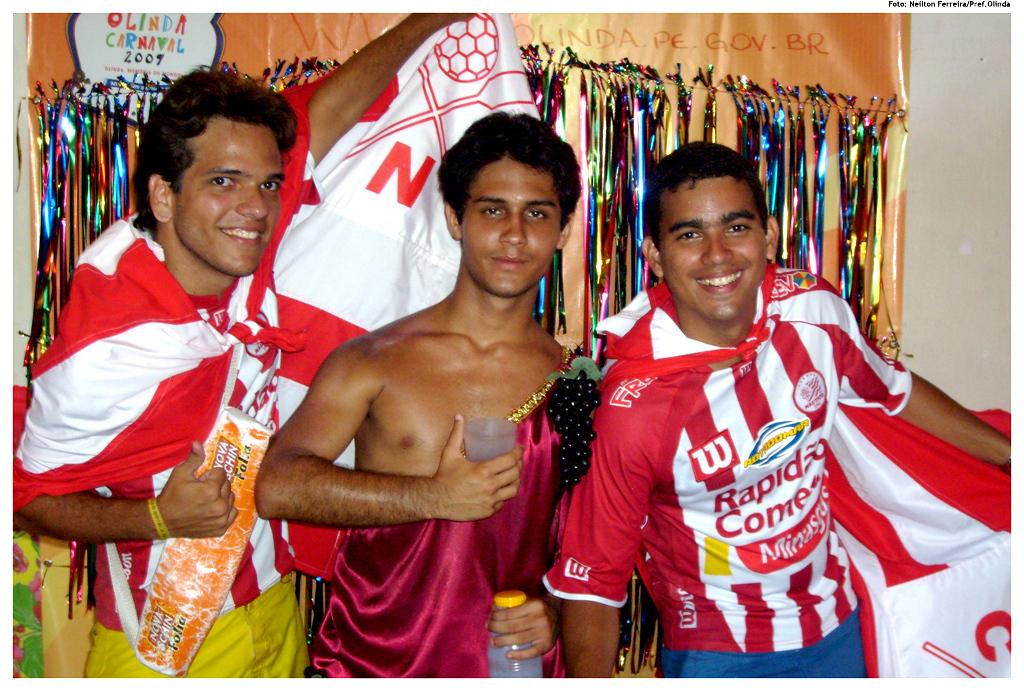<image>
Provide a brief description of the given image. Three guys standing together, the guy on the right has on a shirt that says Rapido something. 